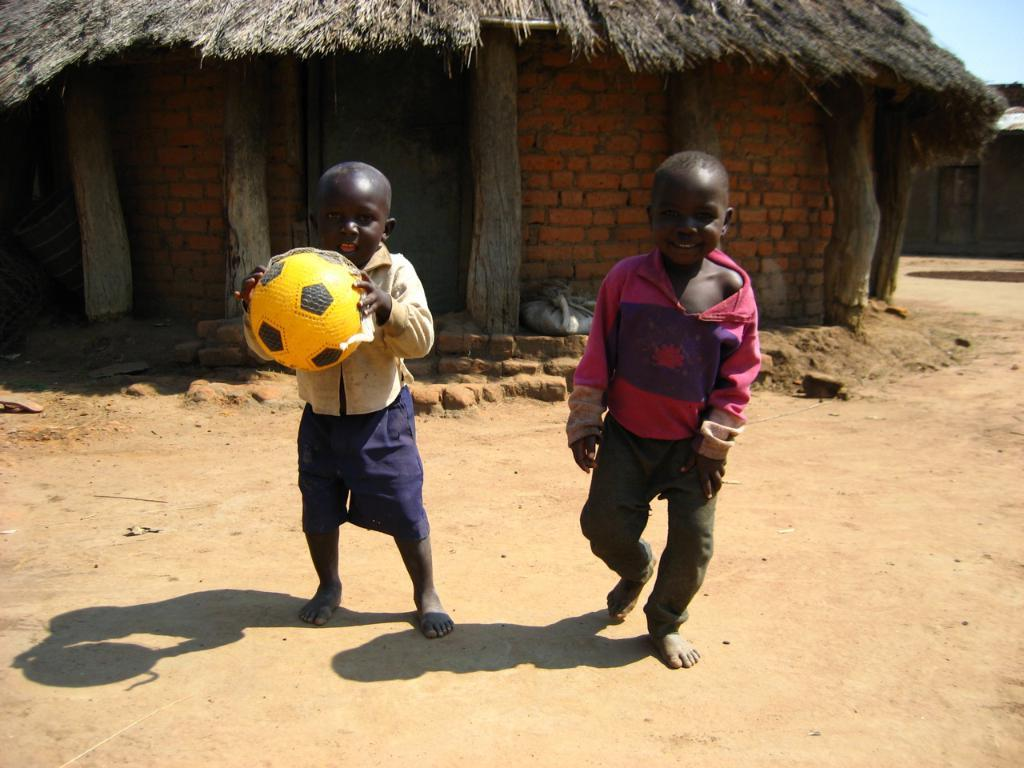How many kids are in the image? There are two kids in the image. What is one of the kids holding? One of the kids is holding a ball. What type of structure is present in the image? There is a house in the image. What is the material used for the house's wall? The wall of the house is made of bricks. What is the uppermost part of the house called? The house has a roof. What type of bikes are parked near the house in the image? There are no bikes present in the image. What kind of trail can be seen leading up to the house in the image? There is no trail present in the image. 